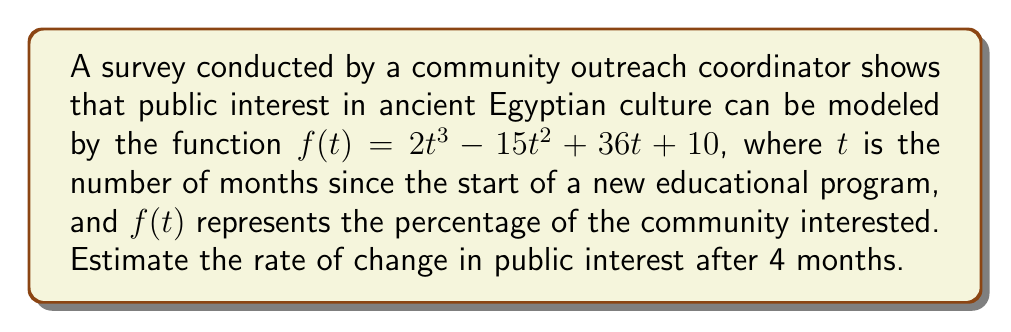Can you solve this math problem? To estimate the rate of change in public interest after 4 months, we need to find the derivative of the given function and evaluate it at $t = 4$. Here's the step-by-step process:

1) The given function is $f(t) = 2t^3 - 15t^2 + 36t + 10$

2) To find the derivative, we apply the power rule and the constant rule:
   $$f'(t) = 6t^2 - 30t + 36$$

3) Now we need to evaluate $f'(4)$:
   $$f'(4) = 6(4)^2 - 30(4) + 36$$

4) Simplify:
   $$f'(4) = 6(16) - 120 + 36$$
   $$f'(4) = 96 - 120 + 36$$
   $$f'(4) = 12$$

5) Interpret the result: The rate of change in public interest after 4 months is 12 percentage points per month.
Answer: 12 percentage points per month 